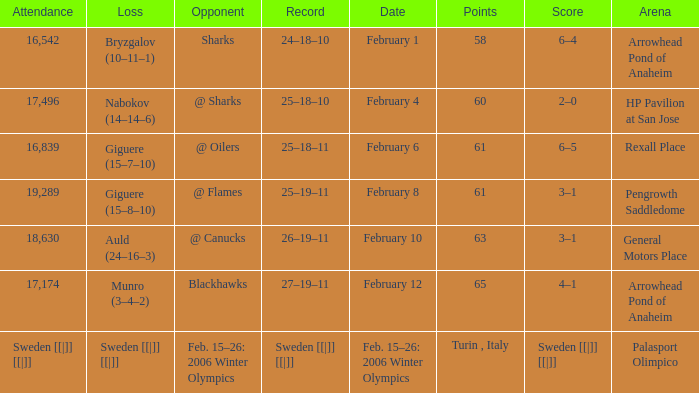Could you parse the entire table? {'header': ['Attendance', 'Loss', 'Opponent', 'Record', 'Date', 'Points', 'Score', 'Arena'], 'rows': [['16,542', 'Bryzgalov (10–11–1)', 'Sharks', '24–18–10', 'February 1', '58', '6–4', 'Arrowhead Pond of Anaheim'], ['17,496', 'Nabokov (14–14–6)', '@ Sharks', '25–18–10', 'February 4', '60', '2–0', 'HP Pavilion at San Jose'], ['16,839', 'Giguere (15–7–10)', '@ Oilers', '25–18–11', 'February 6', '61', '6–5', 'Rexall Place'], ['19,289', 'Giguere (15–8–10)', '@ Flames', '25–19–11', 'February 8', '61', '3–1', 'Pengrowth Saddledome'], ['18,630', 'Auld (24–16–3)', '@ Canucks', '26–19–11', 'February 10', '63', '3–1', 'General Motors Place'], ['17,174', 'Munro (3–4–2)', 'Blackhawks', '27–19–11', 'February 12', '65', '4–1', 'Arrowhead Pond of Anaheim'], ['Sweden [[|]] [[|]]', 'Sweden [[|]] [[|]]', 'Feb. 15–26: 2006 Winter Olympics', 'Sweden [[|]] [[|]]', 'Feb. 15–26: 2006 Winter Olympics', 'Turin , Italy', 'Sweden [[|]] [[|]]', 'Palasport Olimpico']]} What is the points when the score was 3–1, and record was 25–19–11? 61.0. 